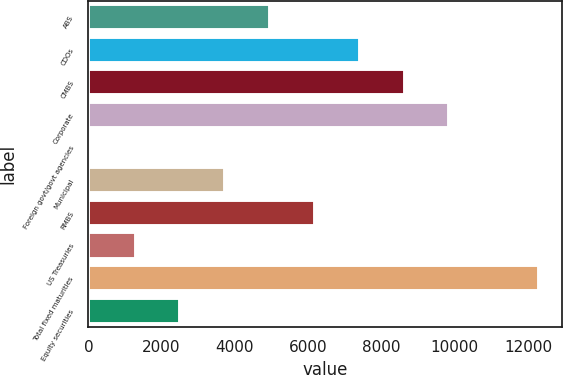<chart> <loc_0><loc_0><loc_500><loc_500><bar_chart><fcel>ABS<fcel>CDOs<fcel>CMBS<fcel>Corporate<fcel>Foreign govt/govt agencies<fcel>Municipal<fcel>RMBS<fcel>US Treasuries<fcel>Total fixed maturities<fcel>Equity securities<nl><fcel>4962.8<fcel>7410.2<fcel>8633.9<fcel>9857.6<fcel>68<fcel>3739.1<fcel>6186.5<fcel>1291.7<fcel>12305<fcel>2515.4<nl></chart> 